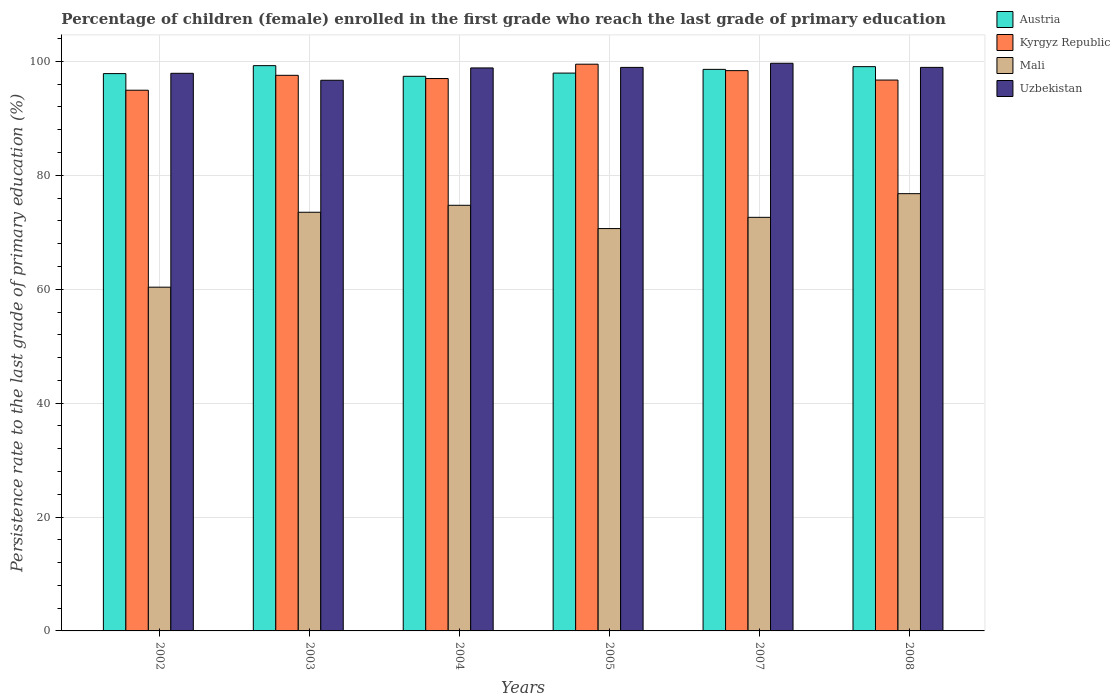How many groups of bars are there?
Make the answer very short. 6. Are the number of bars on each tick of the X-axis equal?
Give a very brief answer. Yes. How many bars are there on the 3rd tick from the left?
Offer a very short reply. 4. What is the label of the 3rd group of bars from the left?
Keep it short and to the point. 2004. In how many cases, is the number of bars for a given year not equal to the number of legend labels?
Keep it short and to the point. 0. What is the persistence rate of children in Austria in 2008?
Provide a succinct answer. 99.08. Across all years, what is the maximum persistence rate of children in Uzbekistan?
Your answer should be compact. 99.68. Across all years, what is the minimum persistence rate of children in Uzbekistan?
Give a very brief answer. 96.69. In which year was the persistence rate of children in Uzbekistan maximum?
Give a very brief answer. 2007. In which year was the persistence rate of children in Kyrgyz Republic minimum?
Provide a short and direct response. 2002. What is the total persistence rate of children in Kyrgyz Republic in the graph?
Offer a very short reply. 584.13. What is the difference between the persistence rate of children in Uzbekistan in 2004 and that in 2007?
Offer a very short reply. -0.82. What is the difference between the persistence rate of children in Uzbekistan in 2003 and the persistence rate of children in Kyrgyz Republic in 2004?
Your response must be concise. -0.3. What is the average persistence rate of children in Austria per year?
Make the answer very short. 98.36. In the year 2003, what is the difference between the persistence rate of children in Uzbekistan and persistence rate of children in Austria?
Give a very brief answer. -2.56. What is the ratio of the persistence rate of children in Uzbekistan in 2005 to that in 2008?
Provide a short and direct response. 1. Is the persistence rate of children in Austria in 2003 less than that in 2004?
Your answer should be compact. No. Is the difference between the persistence rate of children in Uzbekistan in 2002 and 2007 greater than the difference between the persistence rate of children in Austria in 2002 and 2007?
Give a very brief answer. No. What is the difference between the highest and the second highest persistence rate of children in Mali?
Keep it short and to the point. 2.04. What is the difference between the highest and the lowest persistence rate of children in Mali?
Your answer should be very brief. 16.42. In how many years, is the persistence rate of children in Mali greater than the average persistence rate of children in Mali taken over all years?
Offer a terse response. 4. Is the sum of the persistence rate of children in Austria in 2007 and 2008 greater than the maximum persistence rate of children in Uzbekistan across all years?
Provide a short and direct response. Yes. What does the 1st bar from the left in 2003 represents?
Offer a terse response. Austria. Are all the bars in the graph horizontal?
Offer a terse response. No. How many years are there in the graph?
Your response must be concise. 6. What is the difference between two consecutive major ticks on the Y-axis?
Your response must be concise. 20. Are the values on the major ticks of Y-axis written in scientific E-notation?
Your answer should be very brief. No. What is the title of the graph?
Offer a very short reply. Percentage of children (female) enrolled in the first grade who reach the last grade of primary education. Does "Latvia" appear as one of the legend labels in the graph?
Provide a succinct answer. No. What is the label or title of the X-axis?
Give a very brief answer. Years. What is the label or title of the Y-axis?
Offer a terse response. Persistence rate to the last grade of primary education (%). What is the Persistence rate to the last grade of primary education (%) in Austria in 2002?
Make the answer very short. 97.86. What is the Persistence rate to the last grade of primary education (%) in Kyrgyz Republic in 2002?
Offer a terse response. 94.94. What is the Persistence rate to the last grade of primary education (%) of Mali in 2002?
Ensure brevity in your answer.  60.36. What is the Persistence rate to the last grade of primary education (%) in Uzbekistan in 2002?
Your response must be concise. 97.92. What is the Persistence rate to the last grade of primary education (%) in Austria in 2003?
Give a very brief answer. 99.26. What is the Persistence rate to the last grade of primary education (%) in Kyrgyz Republic in 2003?
Your response must be concise. 97.56. What is the Persistence rate to the last grade of primary education (%) of Mali in 2003?
Keep it short and to the point. 73.51. What is the Persistence rate to the last grade of primary education (%) in Uzbekistan in 2003?
Ensure brevity in your answer.  96.69. What is the Persistence rate to the last grade of primary education (%) in Austria in 2004?
Your answer should be very brief. 97.39. What is the Persistence rate to the last grade of primary education (%) of Kyrgyz Republic in 2004?
Give a very brief answer. 97. What is the Persistence rate to the last grade of primary education (%) in Mali in 2004?
Ensure brevity in your answer.  74.74. What is the Persistence rate to the last grade of primary education (%) of Uzbekistan in 2004?
Offer a very short reply. 98.86. What is the Persistence rate to the last grade of primary education (%) of Austria in 2005?
Offer a very short reply. 97.95. What is the Persistence rate to the last grade of primary education (%) in Kyrgyz Republic in 2005?
Make the answer very short. 99.52. What is the Persistence rate to the last grade of primary education (%) in Mali in 2005?
Provide a succinct answer. 70.65. What is the Persistence rate to the last grade of primary education (%) of Uzbekistan in 2005?
Provide a succinct answer. 98.95. What is the Persistence rate to the last grade of primary education (%) of Austria in 2007?
Offer a terse response. 98.61. What is the Persistence rate to the last grade of primary education (%) in Kyrgyz Republic in 2007?
Give a very brief answer. 98.39. What is the Persistence rate to the last grade of primary education (%) in Mali in 2007?
Provide a short and direct response. 72.62. What is the Persistence rate to the last grade of primary education (%) of Uzbekistan in 2007?
Provide a succinct answer. 99.68. What is the Persistence rate to the last grade of primary education (%) in Austria in 2008?
Your response must be concise. 99.08. What is the Persistence rate to the last grade of primary education (%) in Kyrgyz Republic in 2008?
Your answer should be very brief. 96.73. What is the Persistence rate to the last grade of primary education (%) in Mali in 2008?
Your response must be concise. 76.78. What is the Persistence rate to the last grade of primary education (%) in Uzbekistan in 2008?
Ensure brevity in your answer.  98.96. Across all years, what is the maximum Persistence rate to the last grade of primary education (%) in Austria?
Offer a very short reply. 99.26. Across all years, what is the maximum Persistence rate to the last grade of primary education (%) in Kyrgyz Republic?
Provide a short and direct response. 99.52. Across all years, what is the maximum Persistence rate to the last grade of primary education (%) in Mali?
Keep it short and to the point. 76.78. Across all years, what is the maximum Persistence rate to the last grade of primary education (%) of Uzbekistan?
Provide a succinct answer. 99.68. Across all years, what is the minimum Persistence rate to the last grade of primary education (%) of Austria?
Give a very brief answer. 97.39. Across all years, what is the minimum Persistence rate to the last grade of primary education (%) of Kyrgyz Republic?
Your answer should be compact. 94.94. Across all years, what is the minimum Persistence rate to the last grade of primary education (%) in Mali?
Your response must be concise. 60.36. Across all years, what is the minimum Persistence rate to the last grade of primary education (%) of Uzbekistan?
Make the answer very short. 96.69. What is the total Persistence rate to the last grade of primary education (%) of Austria in the graph?
Your answer should be compact. 590.15. What is the total Persistence rate to the last grade of primary education (%) in Kyrgyz Republic in the graph?
Offer a terse response. 584.13. What is the total Persistence rate to the last grade of primary education (%) of Mali in the graph?
Your response must be concise. 428.67. What is the total Persistence rate to the last grade of primary education (%) in Uzbekistan in the graph?
Give a very brief answer. 591.06. What is the difference between the Persistence rate to the last grade of primary education (%) of Austria in 2002 and that in 2003?
Your response must be concise. -1.4. What is the difference between the Persistence rate to the last grade of primary education (%) in Kyrgyz Republic in 2002 and that in 2003?
Your answer should be compact. -2.62. What is the difference between the Persistence rate to the last grade of primary education (%) of Mali in 2002 and that in 2003?
Provide a short and direct response. -13.16. What is the difference between the Persistence rate to the last grade of primary education (%) in Uzbekistan in 2002 and that in 2003?
Provide a short and direct response. 1.22. What is the difference between the Persistence rate to the last grade of primary education (%) of Austria in 2002 and that in 2004?
Make the answer very short. 0.47. What is the difference between the Persistence rate to the last grade of primary education (%) in Kyrgyz Republic in 2002 and that in 2004?
Provide a succinct answer. -2.05. What is the difference between the Persistence rate to the last grade of primary education (%) of Mali in 2002 and that in 2004?
Make the answer very short. -14.38. What is the difference between the Persistence rate to the last grade of primary education (%) of Uzbekistan in 2002 and that in 2004?
Offer a very short reply. -0.94. What is the difference between the Persistence rate to the last grade of primary education (%) in Austria in 2002 and that in 2005?
Keep it short and to the point. -0.09. What is the difference between the Persistence rate to the last grade of primary education (%) of Kyrgyz Republic in 2002 and that in 2005?
Offer a very short reply. -4.57. What is the difference between the Persistence rate to the last grade of primary education (%) in Mali in 2002 and that in 2005?
Offer a terse response. -10.29. What is the difference between the Persistence rate to the last grade of primary education (%) of Uzbekistan in 2002 and that in 2005?
Offer a very short reply. -1.04. What is the difference between the Persistence rate to the last grade of primary education (%) of Austria in 2002 and that in 2007?
Your answer should be compact. -0.74. What is the difference between the Persistence rate to the last grade of primary education (%) of Kyrgyz Republic in 2002 and that in 2007?
Keep it short and to the point. -3.44. What is the difference between the Persistence rate to the last grade of primary education (%) of Mali in 2002 and that in 2007?
Provide a succinct answer. -12.26. What is the difference between the Persistence rate to the last grade of primary education (%) in Uzbekistan in 2002 and that in 2007?
Make the answer very short. -1.76. What is the difference between the Persistence rate to the last grade of primary education (%) of Austria in 2002 and that in 2008?
Ensure brevity in your answer.  -1.22. What is the difference between the Persistence rate to the last grade of primary education (%) of Kyrgyz Republic in 2002 and that in 2008?
Offer a very short reply. -1.78. What is the difference between the Persistence rate to the last grade of primary education (%) in Mali in 2002 and that in 2008?
Offer a terse response. -16.42. What is the difference between the Persistence rate to the last grade of primary education (%) of Uzbekistan in 2002 and that in 2008?
Ensure brevity in your answer.  -1.04. What is the difference between the Persistence rate to the last grade of primary education (%) of Austria in 2003 and that in 2004?
Provide a short and direct response. 1.87. What is the difference between the Persistence rate to the last grade of primary education (%) of Kyrgyz Republic in 2003 and that in 2004?
Keep it short and to the point. 0.57. What is the difference between the Persistence rate to the last grade of primary education (%) in Mali in 2003 and that in 2004?
Your answer should be very brief. -1.22. What is the difference between the Persistence rate to the last grade of primary education (%) of Uzbekistan in 2003 and that in 2004?
Give a very brief answer. -2.17. What is the difference between the Persistence rate to the last grade of primary education (%) in Austria in 2003 and that in 2005?
Offer a very short reply. 1.31. What is the difference between the Persistence rate to the last grade of primary education (%) of Kyrgyz Republic in 2003 and that in 2005?
Offer a very short reply. -1.95. What is the difference between the Persistence rate to the last grade of primary education (%) in Mali in 2003 and that in 2005?
Your answer should be very brief. 2.86. What is the difference between the Persistence rate to the last grade of primary education (%) in Uzbekistan in 2003 and that in 2005?
Provide a succinct answer. -2.26. What is the difference between the Persistence rate to the last grade of primary education (%) of Austria in 2003 and that in 2007?
Your answer should be very brief. 0.65. What is the difference between the Persistence rate to the last grade of primary education (%) in Kyrgyz Republic in 2003 and that in 2007?
Your response must be concise. -0.83. What is the difference between the Persistence rate to the last grade of primary education (%) in Mali in 2003 and that in 2007?
Offer a very short reply. 0.89. What is the difference between the Persistence rate to the last grade of primary education (%) of Uzbekistan in 2003 and that in 2007?
Your response must be concise. -2.98. What is the difference between the Persistence rate to the last grade of primary education (%) of Austria in 2003 and that in 2008?
Ensure brevity in your answer.  0.18. What is the difference between the Persistence rate to the last grade of primary education (%) of Kyrgyz Republic in 2003 and that in 2008?
Offer a terse response. 0.83. What is the difference between the Persistence rate to the last grade of primary education (%) in Mali in 2003 and that in 2008?
Provide a succinct answer. -3.27. What is the difference between the Persistence rate to the last grade of primary education (%) in Uzbekistan in 2003 and that in 2008?
Ensure brevity in your answer.  -2.26. What is the difference between the Persistence rate to the last grade of primary education (%) in Austria in 2004 and that in 2005?
Your answer should be very brief. -0.56. What is the difference between the Persistence rate to the last grade of primary education (%) in Kyrgyz Republic in 2004 and that in 2005?
Offer a terse response. -2.52. What is the difference between the Persistence rate to the last grade of primary education (%) in Mali in 2004 and that in 2005?
Your answer should be very brief. 4.09. What is the difference between the Persistence rate to the last grade of primary education (%) of Uzbekistan in 2004 and that in 2005?
Ensure brevity in your answer.  -0.09. What is the difference between the Persistence rate to the last grade of primary education (%) of Austria in 2004 and that in 2007?
Your answer should be very brief. -1.22. What is the difference between the Persistence rate to the last grade of primary education (%) of Kyrgyz Republic in 2004 and that in 2007?
Your response must be concise. -1.39. What is the difference between the Persistence rate to the last grade of primary education (%) in Mali in 2004 and that in 2007?
Give a very brief answer. 2.11. What is the difference between the Persistence rate to the last grade of primary education (%) of Uzbekistan in 2004 and that in 2007?
Make the answer very short. -0.82. What is the difference between the Persistence rate to the last grade of primary education (%) of Austria in 2004 and that in 2008?
Your response must be concise. -1.69. What is the difference between the Persistence rate to the last grade of primary education (%) in Kyrgyz Republic in 2004 and that in 2008?
Your answer should be compact. 0.27. What is the difference between the Persistence rate to the last grade of primary education (%) of Mali in 2004 and that in 2008?
Offer a very short reply. -2.04. What is the difference between the Persistence rate to the last grade of primary education (%) in Uzbekistan in 2004 and that in 2008?
Keep it short and to the point. -0.1. What is the difference between the Persistence rate to the last grade of primary education (%) in Austria in 2005 and that in 2007?
Keep it short and to the point. -0.65. What is the difference between the Persistence rate to the last grade of primary education (%) in Kyrgyz Republic in 2005 and that in 2007?
Your answer should be compact. 1.13. What is the difference between the Persistence rate to the last grade of primary education (%) in Mali in 2005 and that in 2007?
Offer a very short reply. -1.97. What is the difference between the Persistence rate to the last grade of primary education (%) in Uzbekistan in 2005 and that in 2007?
Provide a short and direct response. -0.73. What is the difference between the Persistence rate to the last grade of primary education (%) in Austria in 2005 and that in 2008?
Provide a short and direct response. -1.13. What is the difference between the Persistence rate to the last grade of primary education (%) of Kyrgyz Republic in 2005 and that in 2008?
Offer a very short reply. 2.79. What is the difference between the Persistence rate to the last grade of primary education (%) in Mali in 2005 and that in 2008?
Offer a terse response. -6.13. What is the difference between the Persistence rate to the last grade of primary education (%) of Uzbekistan in 2005 and that in 2008?
Keep it short and to the point. -0. What is the difference between the Persistence rate to the last grade of primary education (%) of Austria in 2007 and that in 2008?
Provide a short and direct response. -0.48. What is the difference between the Persistence rate to the last grade of primary education (%) in Kyrgyz Republic in 2007 and that in 2008?
Your answer should be very brief. 1.66. What is the difference between the Persistence rate to the last grade of primary education (%) of Mali in 2007 and that in 2008?
Ensure brevity in your answer.  -4.16. What is the difference between the Persistence rate to the last grade of primary education (%) of Uzbekistan in 2007 and that in 2008?
Give a very brief answer. 0.72. What is the difference between the Persistence rate to the last grade of primary education (%) of Austria in 2002 and the Persistence rate to the last grade of primary education (%) of Kyrgyz Republic in 2003?
Your response must be concise. 0.3. What is the difference between the Persistence rate to the last grade of primary education (%) of Austria in 2002 and the Persistence rate to the last grade of primary education (%) of Mali in 2003?
Keep it short and to the point. 24.35. What is the difference between the Persistence rate to the last grade of primary education (%) of Austria in 2002 and the Persistence rate to the last grade of primary education (%) of Uzbekistan in 2003?
Give a very brief answer. 1.17. What is the difference between the Persistence rate to the last grade of primary education (%) of Kyrgyz Republic in 2002 and the Persistence rate to the last grade of primary education (%) of Mali in 2003?
Make the answer very short. 21.43. What is the difference between the Persistence rate to the last grade of primary education (%) in Kyrgyz Republic in 2002 and the Persistence rate to the last grade of primary education (%) in Uzbekistan in 2003?
Ensure brevity in your answer.  -1.75. What is the difference between the Persistence rate to the last grade of primary education (%) of Mali in 2002 and the Persistence rate to the last grade of primary education (%) of Uzbekistan in 2003?
Provide a succinct answer. -36.34. What is the difference between the Persistence rate to the last grade of primary education (%) of Austria in 2002 and the Persistence rate to the last grade of primary education (%) of Kyrgyz Republic in 2004?
Offer a terse response. 0.87. What is the difference between the Persistence rate to the last grade of primary education (%) of Austria in 2002 and the Persistence rate to the last grade of primary education (%) of Mali in 2004?
Your answer should be compact. 23.12. What is the difference between the Persistence rate to the last grade of primary education (%) of Austria in 2002 and the Persistence rate to the last grade of primary education (%) of Uzbekistan in 2004?
Provide a short and direct response. -1. What is the difference between the Persistence rate to the last grade of primary education (%) in Kyrgyz Republic in 2002 and the Persistence rate to the last grade of primary education (%) in Mali in 2004?
Provide a succinct answer. 20.21. What is the difference between the Persistence rate to the last grade of primary education (%) of Kyrgyz Republic in 2002 and the Persistence rate to the last grade of primary education (%) of Uzbekistan in 2004?
Ensure brevity in your answer.  -3.92. What is the difference between the Persistence rate to the last grade of primary education (%) of Mali in 2002 and the Persistence rate to the last grade of primary education (%) of Uzbekistan in 2004?
Ensure brevity in your answer.  -38.5. What is the difference between the Persistence rate to the last grade of primary education (%) in Austria in 2002 and the Persistence rate to the last grade of primary education (%) in Kyrgyz Republic in 2005?
Provide a succinct answer. -1.65. What is the difference between the Persistence rate to the last grade of primary education (%) of Austria in 2002 and the Persistence rate to the last grade of primary education (%) of Mali in 2005?
Your answer should be very brief. 27.21. What is the difference between the Persistence rate to the last grade of primary education (%) of Austria in 2002 and the Persistence rate to the last grade of primary education (%) of Uzbekistan in 2005?
Your answer should be compact. -1.09. What is the difference between the Persistence rate to the last grade of primary education (%) of Kyrgyz Republic in 2002 and the Persistence rate to the last grade of primary education (%) of Mali in 2005?
Offer a terse response. 24.29. What is the difference between the Persistence rate to the last grade of primary education (%) in Kyrgyz Republic in 2002 and the Persistence rate to the last grade of primary education (%) in Uzbekistan in 2005?
Your answer should be very brief. -4.01. What is the difference between the Persistence rate to the last grade of primary education (%) in Mali in 2002 and the Persistence rate to the last grade of primary education (%) in Uzbekistan in 2005?
Offer a terse response. -38.59. What is the difference between the Persistence rate to the last grade of primary education (%) of Austria in 2002 and the Persistence rate to the last grade of primary education (%) of Kyrgyz Republic in 2007?
Your answer should be compact. -0.52. What is the difference between the Persistence rate to the last grade of primary education (%) in Austria in 2002 and the Persistence rate to the last grade of primary education (%) in Mali in 2007?
Your answer should be very brief. 25.24. What is the difference between the Persistence rate to the last grade of primary education (%) in Austria in 2002 and the Persistence rate to the last grade of primary education (%) in Uzbekistan in 2007?
Offer a very short reply. -1.82. What is the difference between the Persistence rate to the last grade of primary education (%) in Kyrgyz Republic in 2002 and the Persistence rate to the last grade of primary education (%) in Mali in 2007?
Offer a terse response. 22.32. What is the difference between the Persistence rate to the last grade of primary education (%) in Kyrgyz Republic in 2002 and the Persistence rate to the last grade of primary education (%) in Uzbekistan in 2007?
Make the answer very short. -4.74. What is the difference between the Persistence rate to the last grade of primary education (%) of Mali in 2002 and the Persistence rate to the last grade of primary education (%) of Uzbekistan in 2007?
Provide a short and direct response. -39.32. What is the difference between the Persistence rate to the last grade of primary education (%) of Austria in 2002 and the Persistence rate to the last grade of primary education (%) of Kyrgyz Republic in 2008?
Give a very brief answer. 1.13. What is the difference between the Persistence rate to the last grade of primary education (%) of Austria in 2002 and the Persistence rate to the last grade of primary education (%) of Mali in 2008?
Your answer should be compact. 21.08. What is the difference between the Persistence rate to the last grade of primary education (%) in Austria in 2002 and the Persistence rate to the last grade of primary education (%) in Uzbekistan in 2008?
Offer a very short reply. -1.09. What is the difference between the Persistence rate to the last grade of primary education (%) in Kyrgyz Republic in 2002 and the Persistence rate to the last grade of primary education (%) in Mali in 2008?
Provide a succinct answer. 18.16. What is the difference between the Persistence rate to the last grade of primary education (%) in Kyrgyz Republic in 2002 and the Persistence rate to the last grade of primary education (%) in Uzbekistan in 2008?
Make the answer very short. -4.01. What is the difference between the Persistence rate to the last grade of primary education (%) of Mali in 2002 and the Persistence rate to the last grade of primary education (%) of Uzbekistan in 2008?
Ensure brevity in your answer.  -38.6. What is the difference between the Persistence rate to the last grade of primary education (%) in Austria in 2003 and the Persistence rate to the last grade of primary education (%) in Kyrgyz Republic in 2004?
Provide a short and direct response. 2.26. What is the difference between the Persistence rate to the last grade of primary education (%) in Austria in 2003 and the Persistence rate to the last grade of primary education (%) in Mali in 2004?
Offer a very short reply. 24.52. What is the difference between the Persistence rate to the last grade of primary education (%) in Austria in 2003 and the Persistence rate to the last grade of primary education (%) in Uzbekistan in 2004?
Provide a short and direct response. 0.4. What is the difference between the Persistence rate to the last grade of primary education (%) of Kyrgyz Republic in 2003 and the Persistence rate to the last grade of primary education (%) of Mali in 2004?
Ensure brevity in your answer.  22.82. What is the difference between the Persistence rate to the last grade of primary education (%) of Kyrgyz Republic in 2003 and the Persistence rate to the last grade of primary education (%) of Uzbekistan in 2004?
Provide a succinct answer. -1.3. What is the difference between the Persistence rate to the last grade of primary education (%) of Mali in 2003 and the Persistence rate to the last grade of primary education (%) of Uzbekistan in 2004?
Keep it short and to the point. -25.35. What is the difference between the Persistence rate to the last grade of primary education (%) of Austria in 2003 and the Persistence rate to the last grade of primary education (%) of Kyrgyz Republic in 2005?
Offer a terse response. -0.26. What is the difference between the Persistence rate to the last grade of primary education (%) in Austria in 2003 and the Persistence rate to the last grade of primary education (%) in Mali in 2005?
Ensure brevity in your answer.  28.61. What is the difference between the Persistence rate to the last grade of primary education (%) of Austria in 2003 and the Persistence rate to the last grade of primary education (%) of Uzbekistan in 2005?
Offer a very short reply. 0.31. What is the difference between the Persistence rate to the last grade of primary education (%) of Kyrgyz Republic in 2003 and the Persistence rate to the last grade of primary education (%) of Mali in 2005?
Make the answer very short. 26.91. What is the difference between the Persistence rate to the last grade of primary education (%) of Kyrgyz Republic in 2003 and the Persistence rate to the last grade of primary education (%) of Uzbekistan in 2005?
Keep it short and to the point. -1.39. What is the difference between the Persistence rate to the last grade of primary education (%) of Mali in 2003 and the Persistence rate to the last grade of primary education (%) of Uzbekistan in 2005?
Give a very brief answer. -25.44. What is the difference between the Persistence rate to the last grade of primary education (%) in Austria in 2003 and the Persistence rate to the last grade of primary education (%) in Kyrgyz Republic in 2007?
Your response must be concise. 0.87. What is the difference between the Persistence rate to the last grade of primary education (%) in Austria in 2003 and the Persistence rate to the last grade of primary education (%) in Mali in 2007?
Your answer should be very brief. 26.63. What is the difference between the Persistence rate to the last grade of primary education (%) of Austria in 2003 and the Persistence rate to the last grade of primary education (%) of Uzbekistan in 2007?
Your answer should be compact. -0.42. What is the difference between the Persistence rate to the last grade of primary education (%) of Kyrgyz Republic in 2003 and the Persistence rate to the last grade of primary education (%) of Mali in 2007?
Give a very brief answer. 24.94. What is the difference between the Persistence rate to the last grade of primary education (%) in Kyrgyz Republic in 2003 and the Persistence rate to the last grade of primary education (%) in Uzbekistan in 2007?
Offer a terse response. -2.12. What is the difference between the Persistence rate to the last grade of primary education (%) in Mali in 2003 and the Persistence rate to the last grade of primary education (%) in Uzbekistan in 2007?
Make the answer very short. -26.16. What is the difference between the Persistence rate to the last grade of primary education (%) of Austria in 2003 and the Persistence rate to the last grade of primary education (%) of Kyrgyz Republic in 2008?
Ensure brevity in your answer.  2.53. What is the difference between the Persistence rate to the last grade of primary education (%) in Austria in 2003 and the Persistence rate to the last grade of primary education (%) in Mali in 2008?
Make the answer very short. 22.48. What is the difference between the Persistence rate to the last grade of primary education (%) in Austria in 2003 and the Persistence rate to the last grade of primary education (%) in Uzbekistan in 2008?
Keep it short and to the point. 0.3. What is the difference between the Persistence rate to the last grade of primary education (%) in Kyrgyz Republic in 2003 and the Persistence rate to the last grade of primary education (%) in Mali in 2008?
Keep it short and to the point. 20.78. What is the difference between the Persistence rate to the last grade of primary education (%) of Kyrgyz Republic in 2003 and the Persistence rate to the last grade of primary education (%) of Uzbekistan in 2008?
Give a very brief answer. -1.39. What is the difference between the Persistence rate to the last grade of primary education (%) of Mali in 2003 and the Persistence rate to the last grade of primary education (%) of Uzbekistan in 2008?
Keep it short and to the point. -25.44. What is the difference between the Persistence rate to the last grade of primary education (%) of Austria in 2004 and the Persistence rate to the last grade of primary education (%) of Kyrgyz Republic in 2005?
Give a very brief answer. -2.13. What is the difference between the Persistence rate to the last grade of primary education (%) in Austria in 2004 and the Persistence rate to the last grade of primary education (%) in Mali in 2005?
Your answer should be very brief. 26.74. What is the difference between the Persistence rate to the last grade of primary education (%) in Austria in 2004 and the Persistence rate to the last grade of primary education (%) in Uzbekistan in 2005?
Your answer should be very brief. -1.56. What is the difference between the Persistence rate to the last grade of primary education (%) in Kyrgyz Republic in 2004 and the Persistence rate to the last grade of primary education (%) in Mali in 2005?
Your response must be concise. 26.34. What is the difference between the Persistence rate to the last grade of primary education (%) in Kyrgyz Republic in 2004 and the Persistence rate to the last grade of primary education (%) in Uzbekistan in 2005?
Your response must be concise. -1.96. What is the difference between the Persistence rate to the last grade of primary education (%) in Mali in 2004 and the Persistence rate to the last grade of primary education (%) in Uzbekistan in 2005?
Your response must be concise. -24.21. What is the difference between the Persistence rate to the last grade of primary education (%) in Austria in 2004 and the Persistence rate to the last grade of primary education (%) in Kyrgyz Republic in 2007?
Offer a very short reply. -1. What is the difference between the Persistence rate to the last grade of primary education (%) in Austria in 2004 and the Persistence rate to the last grade of primary education (%) in Mali in 2007?
Your answer should be compact. 24.77. What is the difference between the Persistence rate to the last grade of primary education (%) in Austria in 2004 and the Persistence rate to the last grade of primary education (%) in Uzbekistan in 2007?
Offer a very short reply. -2.29. What is the difference between the Persistence rate to the last grade of primary education (%) in Kyrgyz Republic in 2004 and the Persistence rate to the last grade of primary education (%) in Mali in 2007?
Offer a very short reply. 24.37. What is the difference between the Persistence rate to the last grade of primary education (%) in Kyrgyz Republic in 2004 and the Persistence rate to the last grade of primary education (%) in Uzbekistan in 2007?
Offer a terse response. -2.68. What is the difference between the Persistence rate to the last grade of primary education (%) of Mali in 2004 and the Persistence rate to the last grade of primary education (%) of Uzbekistan in 2007?
Make the answer very short. -24.94. What is the difference between the Persistence rate to the last grade of primary education (%) in Austria in 2004 and the Persistence rate to the last grade of primary education (%) in Kyrgyz Republic in 2008?
Your answer should be very brief. 0.66. What is the difference between the Persistence rate to the last grade of primary education (%) in Austria in 2004 and the Persistence rate to the last grade of primary education (%) in Mali in 2008?
Ensure brevity in your answer.  20.61. What is the difference between the Persistence rate to the last grade of primary education (%) in Austria in 2004 and the Persistence rate to the last grade of primary education (%) in Uzbekistan in 2008?
Your response must be concise. -1.57. What is the difference between the Persistence rate to the last grade of primary education (%) in Kyrgyz Republic in 2004 and the Persistence rate to the last grade of primary education (%) in Mali in 2008?
Ensure brevity in your answer.  20.21. What is the difference between the Persistence rate to the last grade of primary education (%) in Kyrgyz Republic in 2004 and the Persistence rate to the last grade of primary education (%) in Uzbekistan in 2008?
Ensure brevity in your answer.  -1.96. What is the difference between the Persistence rate to the last grade of primary education (%) of Mali in 2004 and the Persistence rate to the last grade of primary education (%) of Uzbekistan in 2008?
Make the answer very short. -24.22. What is the difference between the Persistence rate to the last grade of primary education (%) of Austria in 2005 and the Persistence rate to the last grade of primary education (%) of Kyrgyz Republic in 2007?
Give a very brief answer. -0.43. What is the difference between the Persistence rate to the last grade of primary education (%) in Austria in 2005 and the Persistence rate to the last grade of primary education (%) in Mali in 2007?
Your answer should be compact. 25.33. What is the difference between the Persistence rate to the last grade of primary education (%) in Austria in 2005 and the Persistence rate to the last grade of primary education (%) in Uzbekistan in 2007?
Ensure brevity in your answer.  -1.73. What is the difference between the Persistence rate to the last grade of primary education (%) of Kyrgyz Republic in 2005 and the Persistence rate to the last grade of primary education (%) of Mali in 2007?
Your answer should be compact. 26.89. What is the difference between the Persistence rate to the last grade of primary education (%) in Kyrgyz Republic in 2005 and the Persistence rate to the last grade of primary education (%) in Uzbekistan in 2007?
Your answer should be compact. -0.16. What is the difference between the Persistence rate to the last grade of primary education (%) in Mali in 2005 and the Persistence rate to the last grade of primary education (%) in Uzbekistan in 2007?
Ensure brevity in your answer.  -29.03. What is the difference between the Persistence rate to the last grade of primary education (%) of Austria in 2005 and the Persistence rate to the last grade of primary education (%) of Kyrgyz Republic in 2008?
Your response must be concise. 1.22. What is the difference between the Persistence rate to the last grade of primary education (%) of Austria in 2005 and the Persistence rate to the last grade of primary education (%) of Mali in 2008?
Provide a succinct answer. 21.17. What is the difference between the Persistence rate to the last grade of primary education (%) of Austria in 2005 and the Persistence rate to the last grade of primary education (%) of Uzbekistan in 2008?
Make the answer very short. -1. What is the difference between the Persistence rate to the last grade of primary education (%) of Kyrgyz Republic in 2005 and the Persistence rate to the last grade of primary education (%) of Mali in 2008?
Offer a very short reply. 22.73. What is the difference between the Persistence rate to the last grade of primary education (%) of Kyrgyz Republic in 2005 and the Persistence rate to the last grade of primary education (%) of Uzbekistan in 2008?
Your answer should be very brief. 0.56. What is the difference between the Persistence rate to the last grade of primary education (%) of Mali in 2005 and the Persistence rate to the last grade of primary education (%) of Uzbekistan in 2008?
Provide a short and direct response. -28.3. What is the difference between the Persistence rate to the last grade of primary education (%) of Austria in 2007 and the Persistence rate to the last grade of primary education (%) of Kyrgyz Republic in 2008?
Ensure brevity in your answer.  1.88. What is the difference between the Persistence rate to the last grade of primary education (%) of Austria in 2007 and the Persistence rate to the last grade of primary education (%) of Mali in 2008?
Offer a terse response. 21.83. What is the difference between the Persistence rate to the last grade of primary education (%) of Austria in 2007 and the Persistence rate to the last grade of primary education (%) of Uzbekistan in 2008?
Offer a terse response. -0.35. What is the difference between the Persistence rate to the last grade of primary education (%) of Kyrgyz Republic in 2007 and the Persistence rate to the last grade of primary education (%) of Mali in 2008?
Provide a short and direct response. 21.61. What is the difference between the Persistence rate to the last grade of primary education (%) of Kyrgyz Republic in 2007 and the Persistence rate to the last grade of primary education (%) of Uzbekistan in 2008?
Your response must be concise. -0.57. What is the difference between the Persistence rate to the last grade of primary education (%) in Mali in 2007 and the Persistence rate to the last grade of primary education (%) in Uzbekistan in 2008?
Provide a succinct answer. -26.33. What is the average Persistence rate to the last grade of primary education (%) in Austria per year?
Offer a very short reply. 98.36. What is the average Persistence rate to the last grade of primary education (%) of Kyrgyz Republic per year?
Offer a very short reply. 97.36. What is the average Persistence rate to the last grade of primary education (%) of Mali per year?
Provide a short and direct response. 71.44. What is the average Persistence rate to the last grade of primary education (%) in Uzbekistan per year?
Give a very brief answer. 98.51. In the year 2002, what is the difference between the Persistence rate to the last grade of primary education (%) of Austria and Persistence rate to the last grade of primary education (%) of Kyrgyz Republic?
Ensure brevity in your answer.  2.92. In the year 2002, what is the difference between the Persistence rate to the last grade of primary education (%) of Austria and Persistence rate to the last grade of primary education (%) of Mali?
Your answer should be compact. 37.5. In the year 2002, what is the difference between the Persistence rate to the last grade of primary education (%) in Austria and Persistence rate to the last grade of primary education (%) in Uzbekistan?
Offer a very short reply. -0.05. In the year 2002, what is the difference between the Persistence rate to the last grade of primary education (%) of Kyrgyz Republic and Persistence rate to the last grade of primary education (%) of Mali?
Provide a short and direct response. 34.58. In the year 2002, what is the difference between the Persistence rate to the last grade of primary education (%) in Kyrgyz Republic and Persistence rate to the last grade of primary education (%) in Uzbekistan?
Ensure brevity in your answer.  -2.97. In the year 2002, what is the difference between the Persistence rate to the last grade of primary education (%) of Mali and Persistence rate to the last grade of primary education (%) of Uzbekistan?
Your answer should be compact. -37.56. In the year 2003, what is the difference between the Persistence rate to the last grade of primary education (%) of Austria and Persistence rate to the last grade of primary education (%) of Kyrgyz Republic?
Offer a very short reply. 1.7. In the year 2003, what is the difference between the Persistence rate to the last grade of primary education (%) in Austria and Persistence rate to the last grade of primary education (%) in Mali?
Ensure brevity in your answer.  25.74. In the year 2003, what is the difference between the Persistence rate to the last grade of primary education (%) of Austria and Persistence rate to the last grade of primary education (%) of Uzbekistan?
Your answer should be very brief. 2.56. In the year 2003, what is the difference between the Persistence rate to the last grade of primary education (%) of Kyrgyz Republic and Persistence rate to the last grade of primary education (%) of Mali?
Ensure brevity in your answer.  24.05. In the year 2003, what is the difference between the Persistence rate to the last grade of primary education (%) in Kyrgyz Republic and Persistence rate to the last grade of primary education (%) in Uzbekistan?
Your response must be concise. 0.87. In the year 2003, what is the difference between the Persistence rate to the last grade of primary education (%) in Mali and Persistence rate to the last grade of primary education (%) in Uzbekistan?
Provide a succinct answer. -23.18. In the year 2004, what is the difference between the Persistence rate to the last grade of primary education (%) in Austria and Persistence rate to the last grade of primary education (%) in Kyrgyz Republic?
Keep it short and to the point. 0.39. In the year 2004, what is the difference between the Persistence rate to the last grade of primary education (%) in Austria and Persistence rate to the last grade of primary education (%) in Mali?
Provide a short and direct response. 22.65. In the year 2004, what is the difference between the Persistence rate to the last grade of primary education (%) in Austria and Persistence rate to the last grade of primary education (%) in Uzbekistan?
Provide a succinct answer. -1.47. In the year 2004, what is the difference between the Persistence rate to the last grade of primary education (%) in Kyrgyz Republic and Persistence rate to the last grade of primary education (%) in Mali?
Your answer should be compact. 22.26. In the year 2004, what is the difference between the Persistence rate to the last grade of primary education (%) in Kyrgyz Republic and Persistence rate to the last grade of primary education (%) in Uzbekistan?
Offer a terse response. -1.86. In the year 2004, what is the difference between the Persistence rate to the last grade of primary education (%) in Mali and Persistence rate to the last grade of primary education (%) in Uzbekistan?
Provide a succinct answer. -24.12. In the year 2005, what is the difference between the Persistence rate to the last grade of primary education (%) of Austria and Persistence rate to the last grade of primary education (%) of Kyrgyz Republic?
Your answer should be very brief. -1.56. In the year 2005, what is the difference between the Persistence rate to the last grade of primary education (%) in Austria and Persistence rate to the last grade of primary education (%) in Mali?
Ensure brevity in your answer.  27.3. In the year 2005, what is the difference between the Persistence rate to the last grade of primary education (%) of Austria and Persistence rate to the last grade of primary education (%) of Uzbekistan?
Give a very brief answer. -1. In the year 2005, what is the difference between the Persistence rate to the last grade of primary education (%) of Kyrgyz Republic and Persistence rate to the last grade of primary education (%) of Mali?
Your response must be concise. 28.86. In the year 2005, what is the difference between the Persistence rate to the last grade of primary education (%) of Kyrgyz Republic and Persistence rate to the last grade of primary education (%) of Uzbekistan?
Offer a very short reply. 0.56. In the year 2005, what is the difference between the Persistence rate to the last grade of primary education (%) in Mali and Persistence rate to the last grade of primary education (%) in Uzbekistan?
Make the answer very short. -28.3. In the year 2007, what is the difference between the Persistence rate to the last grade of primary education (%) of Austria and Persistence rate to the last grade of primary education (%) of Kyrgyz Republic?
Offer a very short reply. 0.22. In the year 2007, what is the difference between the Persistence rate to the last grade of primary education (%) in Austria and Persistence rate to the last grade of primary education (%) in Mali?
Provide a succinct answer. 25.98. In the year 2007, what is the difference between the Persistence rate to the last grade of primary education (%) of Austria and Persistence rate to the last grade of primary education (%) of Uzbekistan?
Ensure brevity in your answer.  -1.07. In the year 2007, what is the difference between the Persistence rate to the last grade of primary education (%) of Kyrgyz Republic and Persistence rate to the last grade of primary education (%) of Mali?
Ensure brevity in your answer.  25.76. In the year 2007, what is the difference between the Persistence rate to the last grade of primary education (%) in Kyrgyz Republic and Persistence rate to the last grade of primary education (%) in Uzbekistan?
Provide a short and direct response. -1.29. In the year 2007, what is the difference between the Persistence rate to the last grade of primary education (%) of Mali and Persistence rate to the last grade of primary education (%) of Uzbekistan?
Provide a short and direct response. -27.06. In the year 2008, what is the difference between the Persistence rate to the last grade of primary education (%) in Austria and Persistence rate to the last grade of primary education (%) in Kyrgyz Republic?
Make the answer very short. 2.35. In the year 2008, what is the difference between the Persistence rate to the last grade of primary education (%) in Austria and Persistence rate to the last grade of primary education (%) in Mali?
Your answer should be very brief. 22.3. In the year 2008, what is the difference between the Persistence rate to the last grade of primary education (%) of Austria and Persistence rate to the last grade of primary education (%) of Uzbekistan?
Your response must be concise. 0.13. In the year 2008, what is the difference between the Persistence rate to the last grade of primary education (%) of Kyrgyz Republic and Persistence rate to the last grade of primary education (%) of Mali?
Make the answer very short. 19.95. In the year 2008, what is the difference between the Persistence rate to the last grade of primary education (%) of Kyrgyz Republic and Persistence rate to the last grade of primary education (%) of Uzbekistan?
Your answer should be very brief. -2.23. In the year 2008, what is the difference between the Persistence rate to the last grade of primary education (%) of Mali and Persistence rate to the last grade of primary education (%) of Uzbekistan?
Your answer should be very brief. -22.18. What is the ratio of the Persistence rate to the last grade of primary education (%) of Austria in 2002 to that in 2003?
Ensure brevity in your answer.  0.99. What is the ratio of the Persistence rate to the last grade of primary education (%) of Kyrgyz Republic in 2002 to that in 2003?
Keep it short and to the point. 0.97. What is the ratio of the Persistence rate to the last grade of primary education (%) of Mali in 2002 to that in 2003?
Make the answer very short. 0.82. What is the ratio of the Persistence rate to the last grade of primary education (%) in Uzbekistan in 2002 to that in 2003?
Your response must be concise. 1.01. What is the ratio of the Persistence rate to the last grade of primary education (%) of Austria in 2002 to that in 2004?
Offer a very short reply. 1. What is the ratio of the Persistence rate to the last grade of primary education (%) of Kyrgyz Republic in 2002 to that in 2004?
Provide a short and direct response. 0.98. What is the ratio of the Persistence rate to the last grade of primary education (%) of Mali in 2002 to that in 2004?
Keep it short and to the point. 0.81. What is the ratio of the Persistence rate to the last grade of primary education (%) in Uzbekistan in 2002 to that in 2004?
Provide a short and direct response. 0.99. What is the ratio of the Persistence rate to the last grade of primary education (%) of Kyrgyz Republic in 2002 to that in 2005?
Offer a terse response. 0.95. What is the ratio of the Persistence rate to the last grade of primary education (%) of Mali in 2002 to that in 2005?
Offer a terse response. 0.85. What is the ratio of the Persistence rate to the last grade of primary education (%) of Kyrgyz Republic in 2002 to that in 2007?
Provide a succinct answer. 0.96. What is the ratio of the Persistence rate to the last grade of primary education (%) of Mali in 2002 to that in 2007?
Provide a short and direct response. 0.83. What is the ratio of the Persistence rate to the last grade of primary education (%) of Uzbekistan in 2002 to that in 2007?
Your answer should be very brief. 0.98. What is the ratio of the Persistence rate to the last grade of primary education (%) in Austria in 2002 to that in 2008?
Your answer should be compact. 0.99. What is the ratio of the Persistence rate to the last grade of primary education (%) of Kyrgyz Republic in 2002 to that in 2008?
Your answer should be compact. 0.98. What is the ratio of the Persistence rate to the last grade of primary education (%) of Mali in 2002 to that in 2008?
Your answer should be compact. 0.79. What is the ratio of the Persistence rate to the last grade of primary education (%) in Austria in 2003 to that in 2004?
Give a very brief answer. 1.02. What is the ratio of the Persistence rate to the last grade of primary education (%) in Mali in 2003 to that in 2004?
Ensure brevity in your answer.  0.98. What is the ratio of the Persistence rate to the last grade of primary education (%) in Uzbekistan in 2003 to that in 2004?
Keep it short and to the point. 0.98. What is the ratio of the Persistence rate to the last grade of primary education (%) in Austria in 2003 to that in 2005?
Provide a short and direct response. 1.01. What is the ratio of the Persistence rate to the last grade of primary education (%) in Kyrgyz Republic in 2003 to that in 2005?
Make the answer very short. 0.98. What is the ratio of the Persistence rate to the last grade of primary education (%) in Mali in 2003 to that in 2005?
Provide a short and direct response. 1.04. What is the ratio of the Persistence rate to the last grade of primary education (%) in Uzbekistan in 2003 to that in 2005?
Offer a very short reply. 0.98. What is the ratio of the Persistence rate to the last grade of primary education (%) in Austria in 2003 to that in 2007?
Provide a short and direct response. 1.01. What is the ratio of the Persistence rate to the last grade of primary education (%) in Kyrgyz Republic in 2003 to that in 2007?
Your answer should be compact. 0.99. What is the ratio of the Persistence rate to the last grade of primary education (%) of Mali in 2003 to that in 2007?
Your answer should be compact. 1.01. What is the ratio of the Persistence rate to the last grade of primary education (%) of Uzbekistan in 2003 to that in 2007?
Ensure brevity in your answer.  0.97. What is the ratio of the Persistence rate to the last grade of primary education (%) of Kyrgyz Republic in 2003 to that in 2008?
Provide a short and direct response. 1.01. What is the ratio of the Persistence rate to the last grade of primary education (%) of Mali in 2003 to that in 2008?
Make the answer very short. 0.96. What is the ratio of the Persistence rate to the last grade of primary education (%) of Uzbekistan in 2003 to that in 2008?
Keep it short and to the point. 0.98. What is the ratio of the Persistence rate to the last grade of primary education (%) in Kyrgyz Republic in 2004 to that in 2005?
Keep it short and to the point. 0.97. What is the ratio of the Persistence rate to the last grade of primary education (%) of Mali in 2004 to that in 2005?
Provide a short and direct response. 1.06. What is the ratio of the Persistence rate to the last grade of primary education (%) in Kyrgyz Republic in 2004 to that in 2007?
Give a very brief answer. 0.99. What is the ratio of the Persistence rate to the last grade of primary education (%) in Mali in 2004 to that in 2007?
Ensure brevity in your answer.  1.03. What is the ratio of the Persistence rate to the last grade of primary education (%) of Uzbekistan in 2004 to that in 2007?
Your answer should be compact. 0.99. What is the ratio of the Persistence rate to the last grade of primary education (%) in Austria in 2004 to that in 2008?
Make the answer very short. 0.98. What is the ratio of the Persistence rate to the last grade of primary education (%) of Kyrgyz Republic in 2004 to that in 2008?
Offer a terse response. 1. What is the ratio of the Persistence rate to the last grade of primary education (%) of Mali in 2004 to that in 2008?
Provide a succinct answer. 0.97. What is the ratio of the Persistence rate to the last grade of primary education (%) in Austria in 2005 to that in 2007?
Your response must be concise. 0.99. What is the ratio of the Persistence rate to the last grade of primary education (%) in Kyrgyz Republic in 2005 to that in 2007?
Your answer should be compact. 1.01. What is the ratio of the Persistence rate to the last grade of primary education (%) in Mali in 2005 to that in 2007?
Provide a short and direct response. 0.97. What is the ratio of the Persistence rate to the last grade of primary education (%) in Kyrgyz Republic in 2005 to that in 2008?
Keep it short and to the point. 1.03. What is the ratio of the Persistence rate to the last grade of primary education (%) of Mali in 2005 to that in 2008?
Your response must be concise. 0.92. What is the ratio of the Persistence rate to the last grade of primary education (%) in Uzbekistan in 2005 to that in 2008?
Ensure brevity in your answer.  1. What is the ratio of the Persistence rate to the last grade of primary education (%) of Kyrgyz Republic in 2007 to that in 2008?
Offer a very short reply. 1.02. What is the ratio of the Persistence rate to the last grade of primary education (%) of Mali in 2007 to that in 2008?
Offer a very short reply. 0.95. What is the ratio of the Persistence rate to the last grade of primary education (%) in Uzbekistan in 2007 to that in 2008?
Keep it short and to the point. 1.01. What is the difference between the highest and the second highest Persistence rate to the last grade of primary education (%) in Austria?
Your response must be concise. 0.18. What is the difference between the highest and the second highest Persistence rate to the last grade of primary education (%) of Kyrgyz Republic?
Provide a short and direct response. 1.13. What is the difference between the highest and the second highest Persistence rate to the last grade of primary education (%) in Mali?
Provide a succinct answer. 2.04. What is the difference between the highest and the second highest Persistence rate to the last grade of primary education (%) of Uzbekistan?
Keep it short and to the point. 0.72. What is the difference between the highest and the lowest Persistence rate to the last grade of primary education (%) in Austria?
Your answer should be compact. 1.87. What is the difference between the highest and the lowest Persistence rate to the last grade of primary education (%) in Kyrgyz Republic?
Your response must be concise. 4.57. What is the difference between the highest and the lowest Persistence rate to the last grade of primary education (%) in Mali?
Your answer should be compact. 16.42. What is the difference between the highest and the lowest Persistence rate to the last grade of primary education (%) in Uzbekistan?
Your answer should be compact. 2.98. 